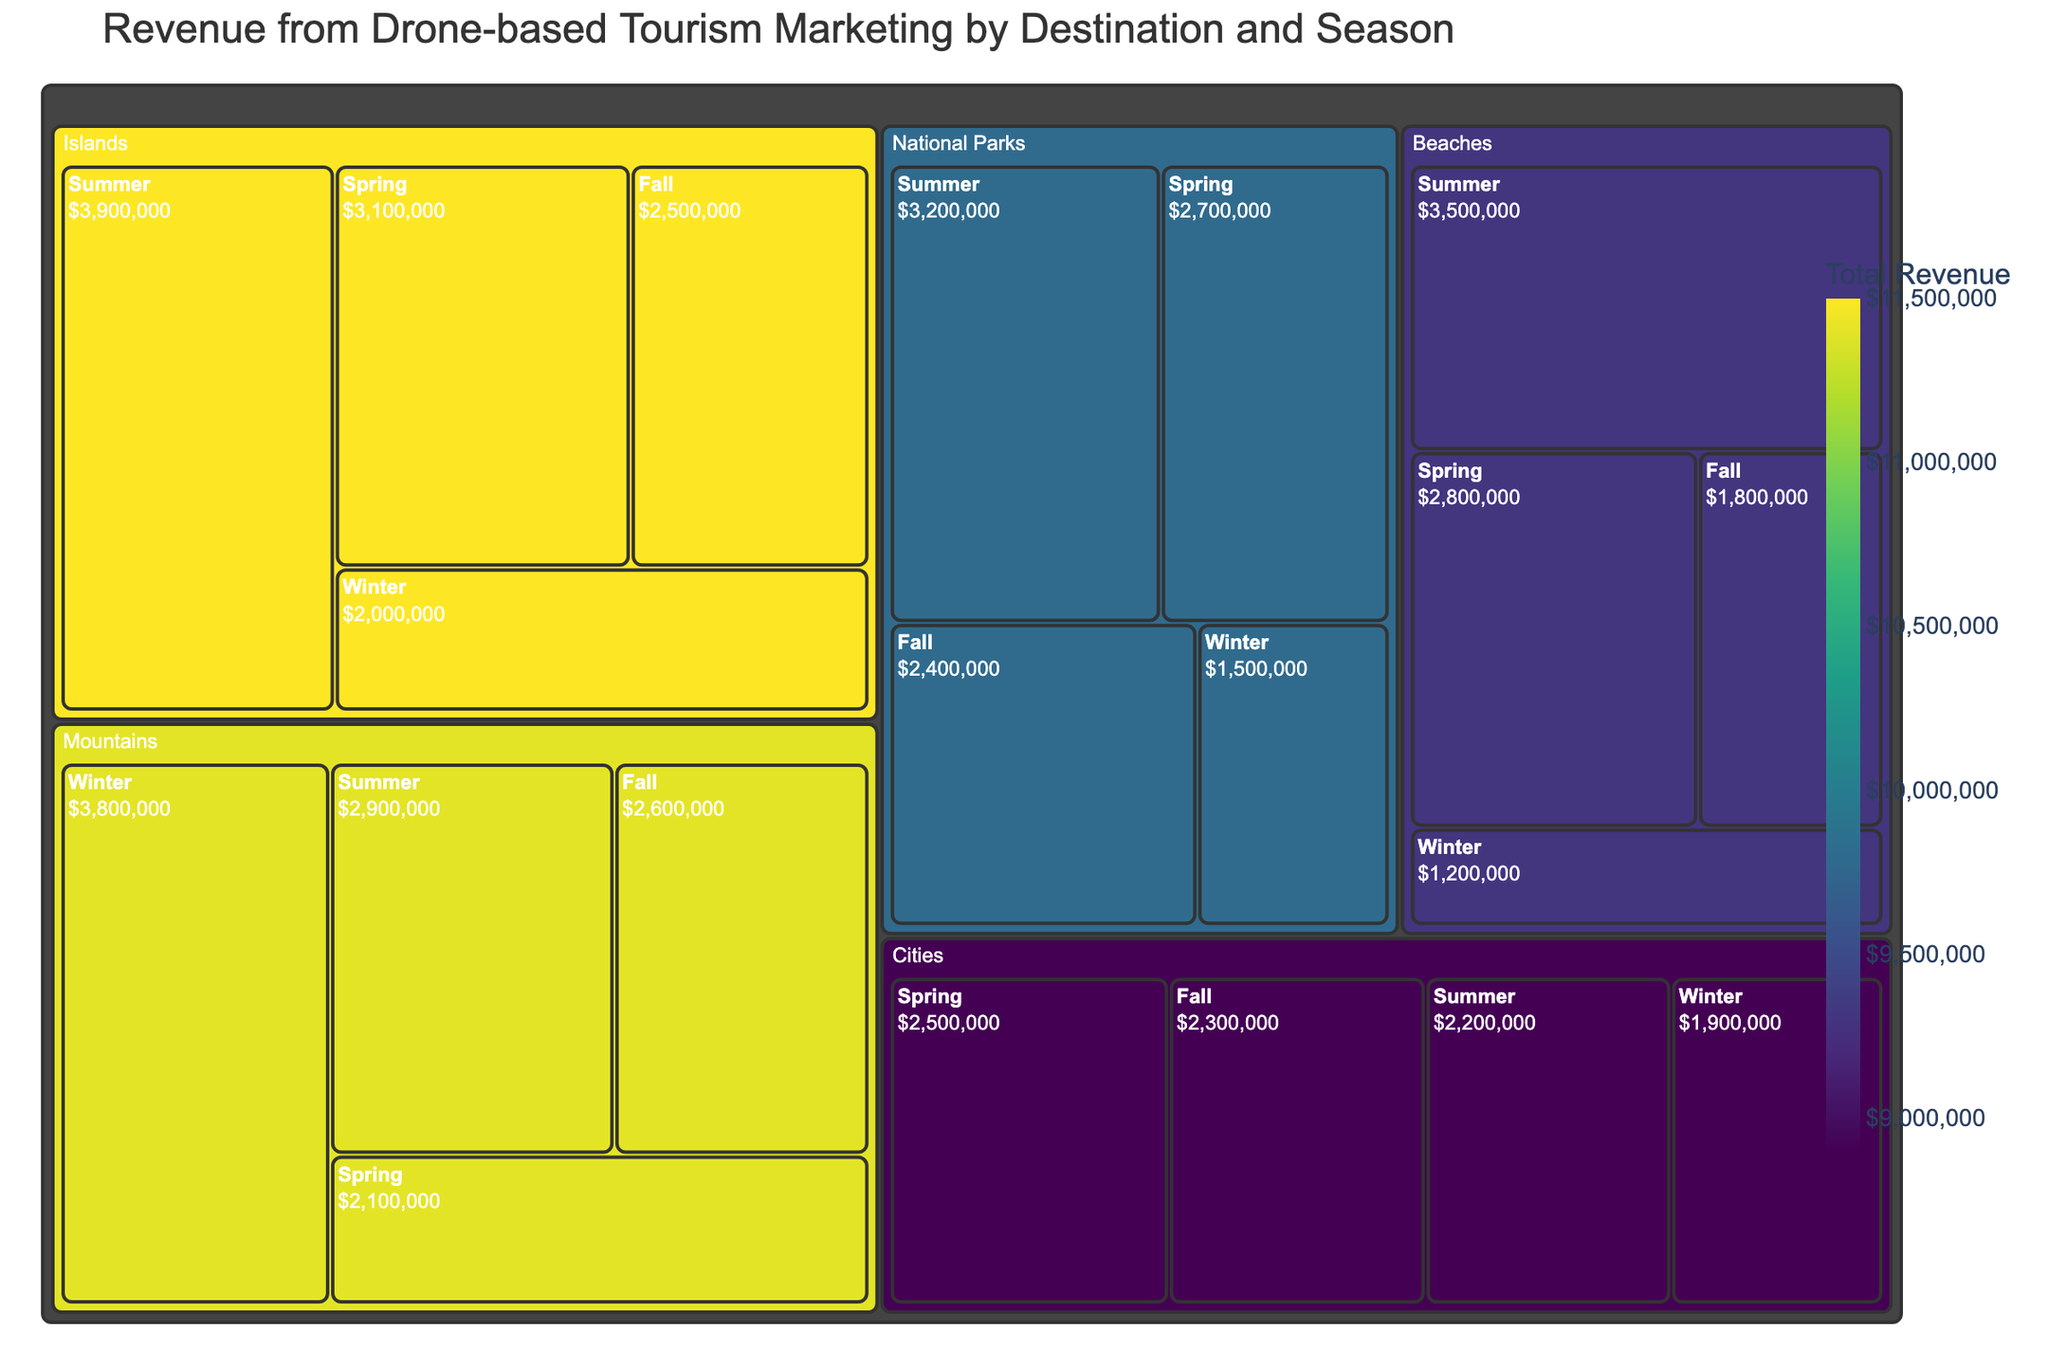What is the title of the treemap? The title is typically displayed at the top of the treemap, summarizing the main subject of the visualization.
Answer: Revenue from Drone-based Tourism Marketing by Destination and Season Which destination type generates the highest total revenue? By looking at the color scale, the destination with the darkest color represents the highest total revenue. From the data given, the 'Islands' segment shows the highest value.
Answer: Islands In which season does the 'Beaches' destination generate the most revenue? For the 'Beaches' destination, check the sub-sections (seasons) to identify the one with the largest area or the highest revenue value. 'Summer' has the largest revenue at $3,500,000.
Answer: Summer Which season generates the least revenue for 'Mountains'? For the 'Mountains' destination, examine the sub-sections (seasons) to find the one with the smallest area or the lowest revenue value. 'Spring' has the smallest revenue at $2,100,000.
Answer: Spring What is the difference in revenue between 'Summer' and 'Winter' for 'National Parks'? Look at the revenue values for 'National Parks' in both 'Summer' ($3,200,000) and 'Winter' ($1,500,000). The difference is calculated as $3,200,000 - $1,500,000.
Answer: $1,700,000 How does the revenue for 'Cities' in the 'Spring' season compare with 'National Parks' in the 'Fall'? Compare the revenue values for 'Cities' in 'Spring' ($2,500,000) with 'National Parks' in 'Fall' ($2,400,000). 'Cities' is slightly higher.
Answer: Cities in Spring is higher Which season shows the most uniform distribution of revenue across all destination types? Look across the seasons and observe the relative sizes and colors of the sections. 'Spring' appears to have relatively balanced revenues across different destinations.
Answer: Spring What is the total revenue generated by 'Beaches' across all seasons? Sum the revenue values for 'Beaches' across 'Summer' ($3,500,000), 'Winter' ($1,200,000), 'Spring' ($2,800,000), and 'Fall' ($1,800,000). The total is $3,500,000 + $1,200,000 + $2,800,000 + $1,800,000.
Answer: $9,300,000 Which destination type sees the largest variance in seasonal revenue figures? For each destination, observe the differences in the sizes and colors of the season sub-sections. 'Beaches' show large variation between 'Summer' and 'Winter'.
Answer: Beaches Compare the revenue generated by 'Islands' in 'Winter' and 'Cities' in 'Summer'. Look at the revenue figures for 'Islands' in 'Winter' ($2,000,000) and 'Cities' in 'Summer' ($2,200,000). 'Cities' in Summer generates slightly more revenue.
Answer: Cities in Summer has more 